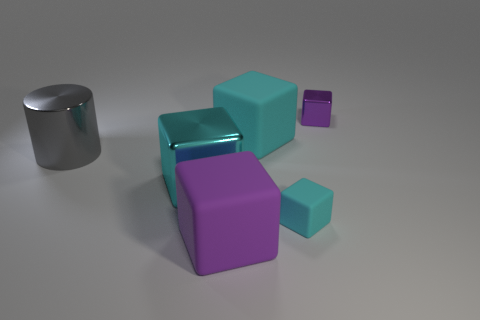Subtract all cyan blocks. How many were subtracted if there are1cyan blocks left? 2 Subtract all gray spheres. How many cyan blocks are left? 3 Subtract all large cyan matte blocks. How many blocks are left? 4 Subtract all red blocks. Subtract all red balls. How many blocks are left? 5 Add 2 red shiny objects. How many objects exist? 8 Subtract all cylinders. How many objects are left? 5 Subtract 0 red cubes. How many objects are left? 6 Subtract all cyan matte things. Subtract all small purple matte spheres. How many objects are left? 4 Add 1 small purple metal objects. How many small purple metal objects are left? 2 Add 1 cylinders. How many cylinders exist? 2 